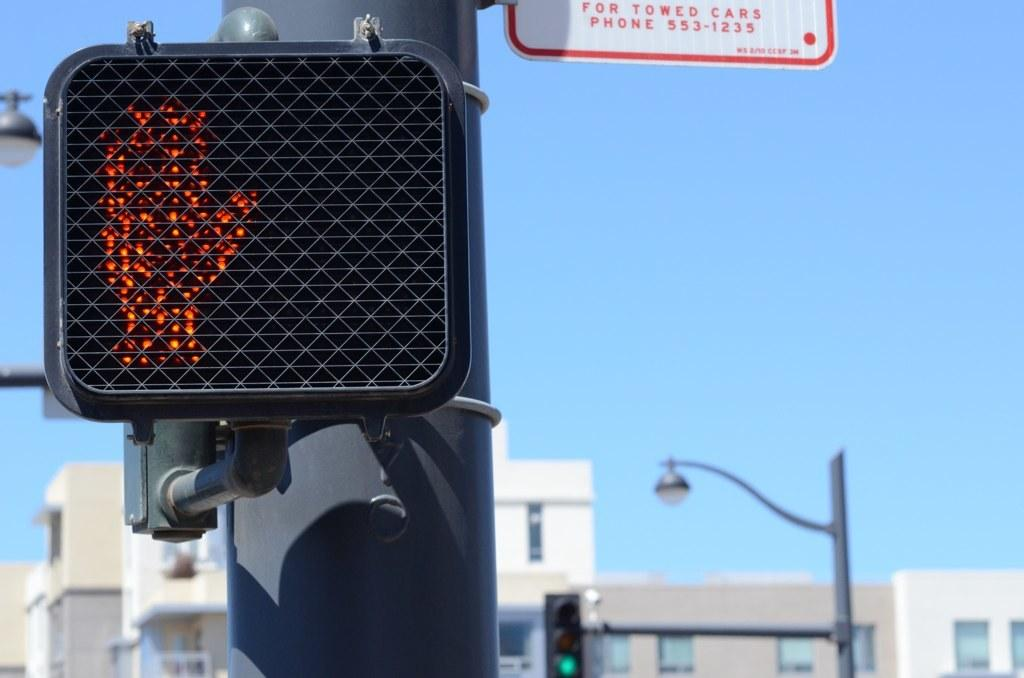What type of structures are present in the image? There are traffic poles, traffic signals, street poles, and street lights in the image. What else can be seen in the image besides these structures? There are buildings in the image. What is visible in the background of the image? The sky is visible in the image. Where is the table located in the image? There is no table present in the image. What type of building is being discussed in the meeting in the image? There is no meeting or building being discussed in the image. 